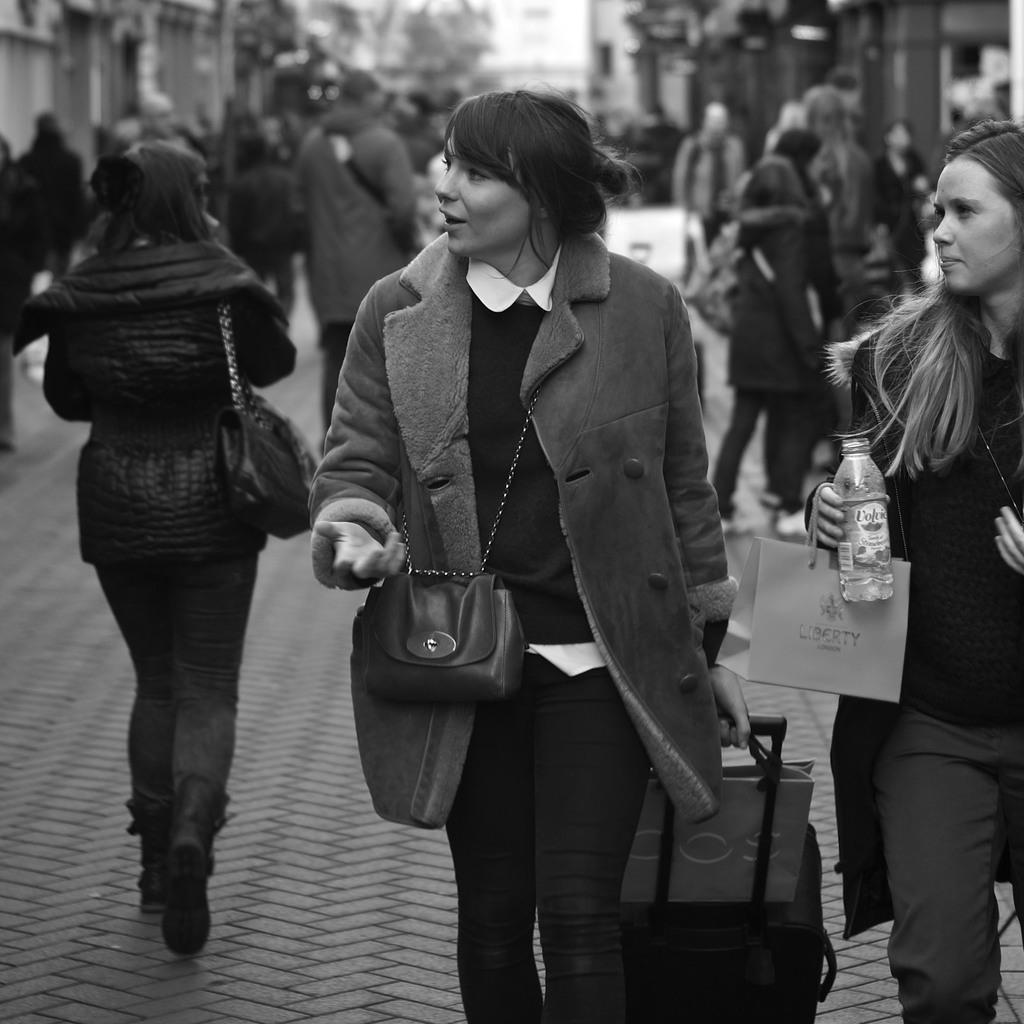How would you summarize this image in a sentence or two? In this image a lady is walking, A lady is wearing a hand bag, A lady is pulling a trolly bag, a group of people standing here ,A lady is holding a water bottle. 